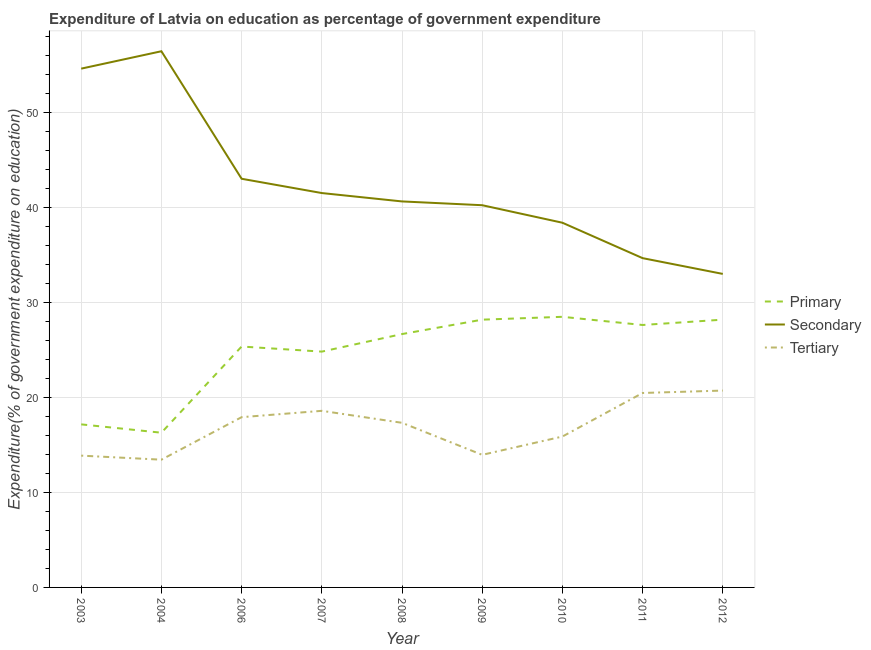How many different coloured lines are there?
Ensure brevity in your answer.  3. Is the number of lines equal to the number of legend labels?
Provide a succinct answer. Yes. What is the expenditure on primary education in 2007?
Offer a terse response. 24.82. Across all years, what is the maximum expenditure on tertiary education?
Make the answer very short. 20.72. Across all years, what is the minimum expenditure on primary education?
Provide a short and direct response. 16.29. In which year was the expenditure on tertiary education maximum?
Your answer should be compact. 2012. In which year was the expenditure on tertiary education minimum?
Offer a very short reply. 2004. What is the total expenditure on primary education in the graph?
Offer a very short reply. 222.81. What is the difference between the expenditure on primary education in 2003 and that in 2008?
Keep it short and to the point. -9.51. What is the difference between the expenditure on secondary education in 2004 and the expenditure on tertiary education in 2009?
Your answer should be very brief. 42.49. What is the average expenditure on secondary education per year?
Give a very brief answer. 42.5. In the year 2007, what is the difference between the expenditure on primary education and expenditure on secondary education?
Provide a short and direct response. -16.69. In how many years, is the expenditure on tertiary education greater than 4 %?
Your answer should be compact. 9. What is the ratio of the expenditure on secondary education in 2006 to that in 2010?
Your answer should be very brief. 1.12. What is the difference between the highest and the second highest expenditure on tertiary education?
Provide a succinct answer. 0.25. What is the difference between the highest and the lowest expenditure on primary education?
Your answer should be very brief. 12.2. In how many years, is the expenditure on secondary education greater than the average expenditure on secondary education taken over all years?
Your answer should be compact. 3. Is the sum of the expenditure on secondary education in 2004 and 2011 greater than the maximum expenditure on primary education across all years?
Make the answer very short. Yes. Is it the case that in every year, the sum of the expenditure on primary education and expenditure on secondary education is greater than the expenditure on tertiary education?
Your response must be concise. Yes. Does the expenditure on secondary education monotonically increase over the years?
Your response must be concise. No. Is the expenditure on tertiary education strictly greater than the expenditure on primary education over the years?
Provide a succinct answer. No. Is the expenditure on tertiary education strictly less than the expenditure on primary education over the years?
Keep it short and to the point. Yes. How many years are there in the graph?
Offer a very short reply. 9. What is the difference between two consecutive major ticks on the Y-axis?
Make the answer very short. 10. Where does the legend appear in the graph?
Your answer should be compact. Center right. How many legend labels are there?
Your response must be concise. 3. What is the title of the graph?
Your response must be concise. Expenditure of Latvia on education as percentage of government expenditure. What is the label or title of the X-axis?
Keep it short and to the point. Year. What is the label or title of the Y-axis?
Your response must be concise. Expenditure(% of government expenditure on education). What is the Expenditure(% of government expenditure on education) of Primary in 2003?
Your answer should be compact. 17.17. What is the Expenditure(% of government expenditure on education) in Secondary in 2003?
Provide a short and direct response. 54.61. What is the Expenditure(% of government expenditure on education) in Tertiary in 2003?
Provide a succinct answer. 13.87. What is the Expenditure(% of government expenditure on education) of Primary in 2004?
Keep it short and to the point. 16.29. What is the Expenditure(% of government expenditure on education) of Secondary in 2004?
Give a very brief answer. 56.45. What is the Expenditure(% of government expenditure on education) in Tertiary in 2004?
Your response must be concise. 13.45. What is the Expenditure(% of government expenditure on education) in Primary in 2006?
Your answer should be very brief. 25.36. What is the Expenditure(% of government expenditure on education) in Secondary in 2006?
Make the answer very short. 43.02. What is the Expenditure(% of government expenditure on education) in Tertiary in 2006?
Your response must be concise. 17.92. What is the Expenditure(% of government expenditure on education) of Primary in 2007?
Provide a short and direct response. 24.82. What is the Expenditure(% of government expenditure on education) of Secondary in 2007?
Provide a short and direct response. 41.52. What is the Expenditure(% of government expenditure on education) in Tertiary in 2007?
Offer a terse response. 18.59. What is the Expenditure(% of government expenditure on education) in Primary in 2008?
Keep it short and to the point. 26.67. What is the Expenditure(% of government expenditure on education) of Secondary in 2008?
Provide a succinct answer. 40.64. What is the Expenditure(% of government expenditure on education) in Tertiary in 2008?
Ensure brevity in your answer.  17.33. What is the Expenditure(% of government expenditure on education) in Primary in 2009?
Ensure brevity in your answer.  28.19. What is the Expenditure(% of government expenditure on education) of Secondary in 2009?
Offer a terse response. 40.24. What is the Expenditure(% of government expenditure on education) of Tertiary in 2009?
Provide a short and direct response. 13.96. What is the Expenditure(% of government expenditure on education) in Primary in 2010?
Your response must be concise. 28.49. What is the Expenditure(% of government expenditure on education) in Secondary in 2010?
Provide a succinct answer. 38.39. What is the Expenditure(% of government expenditure on education) in Tertiary in 2010?
Provide a short and direct response. 15.88. What is the Expenditure(% of government expenditure on education) of Primary in 2011?
Provide a short and direct response. 27.63. What is the Expenditure(% of government expenditure on education) of Secondary in 2011?
Make the answer very short. 34.67. What is the Expenditure(% of government expenditure on education) of Tertiary in 2011?
Provide a succinct answer. 20.47. What is the Expenditure(% of government expenditure on education) in Primary in 2012?
Make the answer very short. 28.19. What is the Expenditure(% of government expenditure on education) of Secondary in 2012?
Your answer should be very brief. 33. What is the Expenditure(% of government expenditure on education) of Tertiary in 2012?
Offer a terse response. 20.72. Across all years, what is the maximum Expenditure(% of government expenditure on education) of Primary?
Give a very brief answer. 28.49. Across all years, what is the maximum Expenditure(% of government expenditure on education) of Secondary?
Ensure brevity in your answer.  56.45. Across all years, what is the maximum Expenditure(% of government expenditure on education) in Tertiary?
Provide a succinct answer. 20.72. Across all years, what is the minimum Expenditure(% of government expenditure on education) of Primary?
Ensure brevity in your answer.  16.29. Across all years, what is the minimum Expenditure(% of government expenditure on education) of Secondary?
Offer a very short reply. 33. Across all years, what is the minimum Expenditure(% of government expenditure on education) in Tertiary?
Offer a very short reply. 13.45. What is the total Expenditure(% of government expenditure on education) of Primary in the graph?
Give a very brief answer. 222.81. What is the total Expenditure(% of government expenditure on education) in Secondary in the graph?
Offer a very short reply. 382.54. What is the total Expenditure(% of government expenditure on education) in Tertiary in the graph?
Make the answer very short. 152.2. What is the difference between the Expenditure(% of government expenditure on education) in Primary in 2003 and that in 2004?
Provide a short and direct response. 0.88. What is the difference between the Expenditure(% of government expenditure on education) in Secondary in 2003 and that in 2004?
Provide a succinct answer. -1.83. What is the difference between the Expenditure(% of government expenditure on education) in Tertiary in 2003 and that in 2004?
Give a very brief answer. 0.43. What is the difference between the Expenditure(% of government expenditure on education) in Primary in 2003 and that in 2006?
Your answer should be very brief. -8.19. What is the difference between the Expenditure(% of government expenditure on education) in Secondary in 2003 and that in 2006?
Keep it short and to the point. 11.59. What is the difference between the Expenditure(% of government expenditure on education) in Tertiary in 2003 and that in 2006?
Your answer should be compact. -4.05. What is the difference between the Expenditure(% of government expenditure on education) in Primary in 2003 and that in 2007?
Ensure brevity in your answer.  -7.66. What is the difference between the Expenditure(% of government expenditure on education) of Secondary in 2003 and that in 2007?
Provide a short and direct response. 13.1. What is the difference between the Expenditure(% of government expenditure on education) of Tertiary in 2003 and that in 2007?
Give a very brief answer. -4.72. What is the difference between the Expenditure(% of government expenditure on education) of Primary in 2003 and that in 2008?
Ensure brevity in your answer.  -9.51. What is the difference between the Expenditure(% of government expenditure on education) of Secondary in 2003 and that in 2008?
Ensure brevity in your answer.  13.98. What is the difference between the Expenditure(% of government expenditure on education) in Tertiary in 2003 and that in 2008?
Offer a terse response. -3.46. What is the difference between the Expenditure(% of government expenditure on education) in Primary in 2003 and that in 2009?
Your response must be concise. -11.02. What is the difference between the Expenditure(% of government expenditure on education) in Secondary in 2003 and that in 2009?
Offer a very short reply. 14.38. What is the difference between the Expenditure(% of government expenditure on education) in Tertiary in 2003 and that in 2009?
Provide a succinct answer. -0.08. What is the difference between the Expenditure(% of government expenditure on education) in Primary in 2003 and that in 2010?
Make the answer very short. -11.32. What is the difference between the Expenditure(% of government expenditure on education) in Secondary in 2003 and that in 2010?
Make the answer very short. 16.22. What is the difference between the Expenditure(% of government expenditure on education) in Tertiary in 2003 and that in 2010?
Make the answer very short. -2.01. What is the difference between the Expenditure(% of government expenditure on education) in Primary in 2003 and that in 2011?
Your response must be concise. -10.46. What is the difference between the Expenditure(% of government expenditure on education) of Secondary in 2003 and that in 2011?
Provide a succinct answer. 19.95. What is the difference between the Expenditure(% of government expenditure on education) of Tertiary in 2003 and that in 2011?
Make the answer very short. -6.6. What is the difference between the Expenditure(% of government expenditure on education) in Primary in 2003 and that in 2012?
Your answer should be very brief. -11.02. What is the difference between the Expenditure(% of government expenditure on education) in Secondary in 2003 and that in 2012?
Keep it short and to the point. 21.61. What is the difference between the Expenditure(% of government expenditure on education) in Tertiary in 2003 and that in 2012?
Provide a short and direct response. -6.85. What is the difference between the Expenditure(% of government expenditure on education) in Primary in 2004 and that in 2006?
Your response must be concise. -9.07. What is the difference between the Expenditure(% of government expenditure on education) in Secondary in 2004 and that in 2006?
Your answer should be compact. 13.42. What is the difference between the Expenditure(% of government expenditure on education) of Tertiary in 2004 and that in 2006?
Your answer should be compact. -4.47. What is the difference between the Expenditure(% of government expenditure on education) of Primary in 2004 and that in 2007?
Your answer should be very brief. -8.54. What is the difference between the Expenditure(% of government expenditure on education) in Secondary in 2004 and that in 2007?
Provide a short and direct response. 14.93. What is the difference between the Expenditure(% of government expenditure on education) in Tertiary in 2004 and that in 2007?
Give a very brief answer. -5.14. What is the difference between the Expenditure(% of government expenditure on education) of Primary in 2004 and that in 2008?
Your answer should be very brief. -10.39. What is the difference between the Expenditure(% of government expenditure on education) of Secondary in 2004 and that in 2008?
Make the answer very short. 15.81. What is the difference between the Expenditure(% of government expenditure on education) in Tertiary in 2004 and that in 2008?
Keep it short and to the point. -3.88. What is the difference between the Expenditure(% of government expenditure on education) of Primary in 2004 and that in 2009?
Ensure brevity in your answer.  -11.9. What is the difference between the Expenditure(% of government expenditure on education) in Secondary in 2004 and that in 2009?
Give a very brief answer. 16.21. What is the difference between the Expenditure(% of government expenditure on education) of Tertiary in 2004 and that in 2009?
Your response must be concise. -0.51. What is the difference between the Expenditure(% of government expenditure on education) of Primary in 2004 and that in 2010?
Provide a short and direct response. -12.2. What is the difference between the Expenditure(% of government expenditure on education) in Secondary in 2004 and that in 2010?
Provide a succinct answer. 18.05. What is the difference between the Expenditure(% of government expenditure on education) of Tertiary in 2004 and that in 2010?
Your response must be concise. -2.44. What is the difference between the Expenditure(% of government expenditure on education) of Primary in 2004 and that in 2011?
Give a very brief answer. -11.34. What is the difference between the Expenditure(% of government expenditure on education) of Secondary in 2004 and that in 2011?
Offer a terse response. 21.78. What is the difference between the Expenditure(% of government expenditure on education) of Tertiary in 2004 and that in 2011?
Ensure brevity in your answer.  -7.02. What is the difference between the Expenditure(% of government expenditure on education) in Primary in 2004 and that in 2012?
Offer a terse response. -11.9. What is the difference between the Expenditure(% of government expenditure on education) in Secondary in 2004 and that in 2012?
Your answer should be compact. 23.44. What is the difference between the Expenditure(% of government expenditure on education) in Tertiary in 2004 and that in 2012?
Offer a terse response. -7.28. What is the difference between the Expenditure(% of government expenditure on education) of Primary in 2006 and that in 2007?
Offer a very short reply. 0.54. What is the difference between the Expenditure(% of government expenditure on education) of Secondary in 2006 and that in 2007?
Offer a terse response. 1.5. What is the difference between the Expenditure(% of government expenditure on education) of Tertiary in 2006 and that in 2007?
Offer a terse response. -0.67. What is the difference between the Expenditure(% of government expenditure on education) of Primary in 2006 and that in 2008?
Offer a very short reply. -1.31. What is the difference between the Expenditure(% of government expenditure on education) in Secondary in 2006 and that in 2008?
Your response must be concise. 2.39. What is the difference between the Expenditure(% of government expenditure on education) in Tertiary in 2006 and that in 2008?
Your answer should be compact. 0.59. What is the difference between the Expenditure(% of government expenditure on education) of Primary in 2006 and that in 2009?
Provide a succinct answer. -2.83. What is the difference between the Expenditure(% of government expenditure on education) in Secondary in 2006 and that in 2009?
Give a very brief answer. 2.78. What is the difference between the Expenditure(% of government expenditure on education) of Tertiary in 2006 and that in 2009?
Provide a succinct answer. 3.97. What is the difference between the Expenditure(% of government expenditure on education) of Primary in 2006 and that in 2010?
Your answer should be compact. -3.13. What is the difference between the Expenditure(% of government expenditure on education) in Secondary in 2006 and that in 2010?
Offer a terse response. 4.63. What is the difference between the Expenditure(% of government expenditure on education) in Tertiary in 2006 and that in 2010?
Provide a succinct answer. 2.04. What is the difference between the Expenditure(% of government expenditure on education) in Primary in 2006 and that in 2011?
Your answer should be compact. -2.27. What is the difference between the Expenditure(% of government expenditure on education) in Secondary in 2006 and that in 2011?
Ensure brevity in your answer.  8.36. What is the difference between the Expenditure(% of government expenditure on education) in Tertiary in 2006 and that in 2011?
Ensure brevity in your answer.  -2.55. What is the difference between the Expenditure(% of government expenditure on education) in Primary in 2006 and that in 2012?
Offer a terse response. -2.83. What is the difference between the Expenditure(% of government expenditure on education) of Secondary in 2006 and that in 2012?
Your answer should be compact. 10.02. What is the difference between the Expenditure(% of government expenditure on education) in Tertiary in 2006 and that in 2012?
Offer a terse response. -2.8. What is the difference between the Expenditure(% of government expenditure on education) of Primary in 2007 and that in 2008?
Provide a short and direct response. -1.85. What is the difference between the Expenditure(% of government expenditure on education) of Secondary in 2007 and that in 2008?
Make the answer very short. 0.88. What is the difference between the Expenditure(% of government expenditure on education) in Tertiary in 2007 and that in 2008?
Provide a succinct answer. 1.26. What is the difference between the Expenditure(% of government expenditure on education) of Primary in 2007 and that in 2009?
Your answer should be very brief. -3.36. What is the difference between the Expenditure(% of government expenditure on education) of Secondary in 2007 and that in 2009?
Your answer should be compact. 1.28. What is the difference between the Expenditure(% of government expenditure on education) in Tertiary in 2007 and that in 2009?
Your response must be concise. 4.63. What is the difference between the Expenditure(% of government expenditure on education) of Primary in 2007 and that in 2010?
Offer a very short reply. -3.66. What is the difference between the Expenditure(% of government expenditure on education) in Secondary in 2007 and that in 2010?
Offer a terse response. 3.12. What is the difference between the Expenditure(% of government expenditure on education) of Tertiary in 2007 and that in 2010?
Give a very brief answer. 2.71. What is the difference between the Expenditure(% of government expenditure on education) of Primary in 2007 and that in 2011?
Offer a terse response. -2.8. What is the difference between the Expenditure(% of government expenditure on education) of Secondary in 2007 and that in 2011?
Give a very brief answer. 6.85. What is the difference between the Expenditure(% of government expenditure on education) of Tertiary in 2007 and that in 2011?
Provide a short and direct response. -1.88. What is the difference between the Expenditure(% of government expenditure on education) of Primary in 2007 and that in 2012?
Offer a terse response. -3.37. What is the difference between the Expenditure(% of government expenditure on education) of Secondary in 2007 and that in 2012?
Your answer should be very brief. 8.51. What is the difference between the Expenditure(% of government expenditure on education) of Tertiary in 2007 and that in 2012?
Your response must be concise. -2.13. What is the difference between the Expenditure(% of government expenditure on education) in Primary in 2008 and that in 2009?
Your answer should be compact. -1.52. What is the difference between the Expenditure(% of government expenditure on education) in Secondary in 2008 and that in 2009?
Offer a terse response. 0.4. What is the difference between the Expenditure(% of government expenditure on education) in Tertiary in 2008 and that in 2009?
Your response must be concise. 3.37. What is the difference between the Expenditure(% of government expenditure on education) of Primary in 2008 and that in 2010?
Your response must be concise. -1.82. What is the difference between the Expenditure(% of government expenditure on education) in Secondary in 2008 and that in 2010?
Offer a terse response. 2.24. What is the difference between the Expenditure(% of government expenditure on education) in Tertiary in 2008 and that in 2010?
Provide a succinct answer. 1.45. What is the difference between the Expenditure(% of government expenditure on education) of Primary in 2008 and that in 2011?
Offer a very short reply. -0.96. What is the difference between the Expenditure(% of government expenditure on education) in Secondary in 2008 and that in 2011?
Make the answer very short. 5.97. What is the difference between the Expenditure(% of government expenditure on education) of Tertiary in 2008 and that in 2011?
Ensure brevity in your answer.  -3.14. What is the difference between the Expenditure(% of government expenditure on education) of Primary in 2008 and that in 2012?
Keep it short and to the point. -1.52. What is the difference between the Expenditure(% of government expenditure on education) of Secondary in 2008 and that in 2012?
Your response must be concise. 7.63. What is the difference between the Expenditure(% of government expenditure on education) in Tertiary in 2008 and that in 2012?
Keep it short and to the point. -3.39. What is the difference between the Expenditure(% of government expenditure on education) of Secondary in 2009 and that in 2010?
Keep it short and to the point. 1.84. What is the difference between the Expenditure(% of government expenditure on education) of Tertiary in 2009 and that in 2010?
Offer a very short reply. -1.93. What is the difference between the Expenditure(% of government expenditure on education) of Primary in 2009 and that in 2011?
Your response must be concise. 0.56. What is the difference between the Expenditure(% of government expenditure on education) of Secondary in 2009 and that in 2011?
Provide a succinct answer. 5.57. What is the difference between the Expenditure(% of government expenditure on education) of Tertiary in 2009 and that in 2011?
Provide a succinct answer. -6.51. What is the difference between the Expenditure(% of government expenditure on education) in Primary in 2009 and that in 2012?
Give a very brief answer. -0. What is the difference between the Expenditure(% of government expenditure on education) of Secondary in 2009 and that in 2012?
Your response must be concise. 7.23. What is the difference between the Expenditure(% of government expenditure on education) of Tertiary in 2009 and that in 2012?
Your response must be concise. -6.77. What is the difference between the Expenditure(% of government expenditure on education) in Primary in 2010 and that in 2011?
Your response must be concise. 0.86. What is the difference between the Expenditure(% of government expenditure on education) in Secondary in 2010 and that in 2011?
Make the answer very short. 3.73. What is the difference between the Expenditure(% of government expenditure on education) of Tertiary in 2010 and that in 2011?
Your answer should be very brief. -4.59. What is the difference between the Expenditure(% of government expenditure on education) of Primary in 2010 and that in 2012?
Make the answer very short. 0.3. What is the difference between the Expenditure(% of government expenditure on education) in Secondary in 2010 and that in 2012?
Provide a short and direct response. 5.39. What is the difference between the Expenditure(% of government expenditure on education) in Tertiary in 2010 and that in 2012?
Your answer should be compact. -4.84. What is the difference between the Expenditure(% of government expenditure on education) of Primary in 2011 and that in 2012?
Give a very brief answer. -0.56. What is the difference between the Expenditure(% of government expenditure on education) in Secondary in 2011 and that in 2012?
Keep it short and to the point. 1.66. What is the difference between the Expenditure(% of government expenditure on education) in Tertiary in 2011 and that in 2012?
Your response must be concise. -0.25. What is the difference between the Expenditure(% of government expenditure on education) of Primary in 2003 and the Expenditure(% of government expenditure on education) of Secondary in 2004?
Your answer should be compact. -39.28. What is the difference between the Expenditure(% of government expenditure on education) in Primary in 2003 and the Expenditure(% of government expenditure on education) in Tertiary in 2004?
Your answer should be very brief. 3.72. What is the difference between the Expenditure(% of government expenditure on education) of Secondary in 2003 and the Expenditure(% of government expenditure on education) of Tertiary in 2004?
Provide a short and direct response. 41.17. What is the difference between the Expenditure(% of government expenditure on education) in Primary in 2003 and the Expenditure(% of government expenditure on education) in Secondary in 2006?
Ensure brevity in your answer.  -25.86. What is the difference between the Expenditure(% of government expenditure on education) in Primary in 2003 and the Expenditure(% of government expenditure on education) in Tertiary in 2006?
Provide a short and direct response. -0.76. What is the difference between the Expenditure(% of government expenditure on education) of Secondary in 2003 and the Expenditure(% of government expenditure on education) of Tertiary in 2006?
Keep it short and to the point. 36.69. What is the difference between the Expenditure(% of government expenditure on education) of Primary in 2003 and the Expenditure(% of government expenditure on education) of Secondary in 2007?
Make the answer very short. -24.35. What is the difference between the Expenditure(% of government expenditure on education) of Primary in 2003 and the Expenditure(% of government expenditure on education) of Tertiary in 2007?
Make the answer very short. -1.42. What is the difference between the Expenditure(% of government expenditure on education) in Secondary in 2003 and the Expenditure(% of government expenditure on education) in Tertiary in 2007?
Your response must be concise. 36.02. What is the difference between the Expenditure(% of government expenditure on education) of Primary in 2003 and the Expenditure(% of government expenditure on education) of Secondary in 2008?
Offer a very short reply. -23.47. What is the difference between the Expenditure(% of government expenditure on education) of Primary in 2003 and the Expenditure(% of government expenditure on education) of Tertiary in 2008?
Offer a terse response. -0.16. What is the difference between the Expenditure(% of government expenditure on education) of Secondary in 2003 and the Expenditure(% of government expenditure on education) of Tertiary in 2008?
Your answer should be compact. 37.28. What is the difference between the Expenditure(% of government expenditure on education) of Primary in 2003 and the Expenditure(% of government expenditure on education) of Secondary in 2009?
Ensure brevity in your answer.  -23.07. What is the difference between the Expenditure(% of government expenditure on education) of Primary in 2003 and the Expenditure(% of government expenditure on education) of Tertiary in 2009?
Offer a terse response. 3.21. What is the difference between the Expenditure(% of government expenditure on education) in Secondary in 2003 and the Expenditure(% of government expenditure on education) in Tertiary in 2009?
Your response must be concise. 40.66. What is the difference between the Expenditure(% of government expenditure on education) of Primary in 2003 and the Expenditure(% of government expenditure on education) of Secondary in 2010?
Offer a terse response. -21.23. What is the difference between the Expenditure(% of government expenditure on education) in Primary in 2003 and the Expenditure(% of government expenditure on education) in Tertiary in 2010?
Ensure brevity in your answer.  1.28. What is the difference between the Expenditure(% of government expenditure on education) in Secondary in 2003 and the Expenditure(% of government expenditure on education) in Tertiary in 2010?
Offer a terse response. 38.73. What is the difference between the Expenditure(% of government expenditure on education) in Primary in 2003 and the Expenditure(% of government expenditure on education) in Secondary in 2011?
Make the answer very short. -17.5. What is the difference between the Expenditure(% of government expenditure on education) in Primary in 2003 and the Expenditure(% of government expenditure on education) in Tertiary in 2011?
Your response must be concise. -3.3. What is the difference between the Expenditure(% of government expenditure on education) in Secondary in 2003 and the Expenditure(% of government expenditure on education) in Tertiary in 2011?
Ensure brevity in your answer.  34.14. What is the difference between the Expenditure(% of government expenditure on education) in Primary in 2003 and the Expenditure(% of government expenditure on education) in Secondary in 2012?
Your response must be concise. -15.84. What is the difference between the Expenditure(% of government expenditure on education) in Primary in 2003 and the Expenditure(% of government expenditure on education) in Tertiary in 2012?
Keep it short and to the point. -3.56. What is the difference between the Expenditure(% of government expenditure on education) of Secondary in 2003 and the Expenditure(% of government expenditure on education) of Tertiary in 2012?
Your answer should be compact. 33.89. What is the difference between the Expenditure(% of government expenditure on education) of Primary in 2004 and the Expenditure(% of government expenditure on education) of Secondary in 2006?
Offer a terse response. -26.74. What is the difference between the Expenditure(% of government expenditure on education) of Primary in 2004 and the Expenditure(% of government expenditure on education) of Tertiary in 2006?
Provide a short and direct response. -1.64. What is the difference between the Expenditure(% of government expenditure on education) of Secondary in 2004 and the Expenditure(% of government expenditure on education) of Tertiary in 2006?
Offer a terse response. 38.52. What is the difference between the Expenditure(% of government expenditure on education) in Primary in 2004 and the Expenditure(% of government expenditure on education) in Secondary in 2007?
Ensure brevity in your answer.  -25.23. What is the difference between the Expenditure(% of government expenditure on education) of Primary in 2004 and the Expenditure(% of government expenditure on education) of Tertiary in 2007?
Offer a very short reply. -2.3. What is the difference between the Expenditure(% of government expenditure on education) of Secondary in 2004 and the Expenditure(% of government expenditure on education) of Tertiary in 2007?
Your answer should be very brief. 37.85. What is the difference between the Expenditure(% of government expenditure on education) of Primary in 2004 and the Expenditure(% of government expenditure on education) of Secondary in 2008?
Your answer should be compact. -24.35. What is the difference between the Expenditure(% of government expenditure on education) of Primary in 2004 and the Expenditure(% of government expenditure on education) of Tertiary in 2008?
Keep it short and to the point. -1.04. What is the difference between the Expenditure(% of government expenditure on education) of Secondary in 2004 and the Expenditure(% of government expenditure on education) of Tertiary in 2008?
Ensure brevity in your answer.  39.11. What is the difference between the Expenditure(% of government expenditure on education) of Primary in 2004 and the Expenditure(% of government expenditure on education) of Secondary in 2009?
Make the answer very short. -23.95. What is the difference between the Expenditure(% of government expenditure on education) in Primary in 2004 and the Expenditure(% of government expenditure on education) in Tertiary in 2009?
Provide a succinct answer. 2.33. What is the difference between the Expenditure(% of government expenditure on education) of Secondary in 2004 and the Expenditure(% of government expenditure on education) of Tertiary in 2009?
Provide a succinct answer. 42.49. What is the difference between the Expenditure(% of government expenditure on education) of Primary in 2004 and the Expenditure(% of government expenditure on education) of Secondary in 2010?
Make the answer very short. -22.11. What is the difference between the Expenditure(% of government expenditure on education) of Primary in 2004 and the Expenditure(% of government expenditure on education) of Tertiary in 2010?
Offer a very short reply. 0.4. What is the difference between the Expenditure(% of government expenditure on education) of Secondary in 2004 and the Expenditure(% of government expenditure on education) of Tertiary in 2010?
Your answer should be compact. 40.56. What is the difference between the Expenditure(% of government expenditure on education) of Primary in 2004 and the Expenditure(% of government expenditure on education) of Secondary in 2011?
Your answer should be compact. -18.38. What is the difference between the Expenditure(% of government expenditure on education) of Primary in 2004 and the Expenditure(% of government expenditure on education) of Tertiary in 2011?
Ensure brevity in your answer.  -4.18. What is the difference between the Expenditure(% of government expenditure on education) of Secondary in 2004 and the Expenditure(% of government expenditure on education) of Tertiary in 2011?
Provide a short and direct response. 35.98. What is the difference between the Expenditure(% of government expenditure on education) in Primary in 2004 and the Expenditure(% of government expenditure on education) in Secondary in 2012?
Keep it short and to the point. -16.72. What is the difference between the Expenditure(% of government expenditure on education) of Primary in 2004 and the Expenditure(% of government expenditure on education) of Tertiary in 2012?
Your answer should be compact. -4.44. What is the difference between the Expenditure(% of government expenditure on education) in Secondary in 2004 and the Expenditure(% of government expenditure on education) in Tertiary in 2012?
Your answer should be very brief. 35.72. What is the difference between the Expenditure(% of government expenditure on education) of Primary in 2006 and the Expenditure(% of government expenditure on education) of Secondary in 2007?
Make the answer very short. -16.16. What is the difference between the Expenditure(% of government expenditure on education) in Primary in 2006 and the Expenditure(% of government expenditure on education) in Tertiary in 2007?
Offer a very short reply. 6.77. What is the difference between the Expenditure(% of government expenditure on education) in Secondary in 2006 and the Expenditure(% of government expenditure on education) in Tertiary in 2007?
Provide a short and direct response. 24.43. What is the difference between the Expenditure(% of government expenditure on education) of Primary in 2006 and the Expenditure(% of government expenditure on education) of Secondary in 2008?
Offer a terse response. -15.28. What is the difference between the Expenditure(% of government expenditure on education) of Primary in 2006 and the Expenditure(% of government expenditure on education) of Tertiary in 2008?
Make the answer very short. 8.03. What is the difference between the Expenditure(% of government expenditure on education) in Secondary in 2006 and the Expenditure(% of government expenditure on education) in Tertiary in 2008?
Provide a short and direct response. 25.69. What is the difference between the Expenditure(% of government expenditure on education) in Primary in 2006 and the Expenditure(% of government expenditure on education) in Secondary in 2009?
Keep it short and to the point. -14.88. What is the difference between the Expenditure(% of government expenditure on education) of Primary in 2006 and the Expenditure(% of government expenditure on education) of Tertiary in 2009?
Keep it short and to the point. 11.4. What is the difference between the Expenditure(% of government expenditure on education) in Secondary in 2006 and the Expenditure(% of government expenditure on education) in Tertiary in 2009?
Your answer should be very brief. 29.06. What is the difference between the Expenditure(% of government expenditure on education) of Primary in 2006 and the Expenditure(% of government expenditure on education) of Secondary in 2010?
Your response must be concise. -13.03. What is the difference between the Expenditure(% of government expenditure on education) in Primary in 2006 and the Expenditure(% of government expenditure on education) in Tertiary in 2010?
Offer a very short reply. 9.48. What is the difference between the Expenditure(% of government expenditure on education) of Secondary in 2006 and the Expenditure(% of government expenditure on education) of Tertiary in 2010?
Keep it short and to the point. 27.14. What is the difference between the Expenditure(% of government expenditure on education) of Primary in 2006 and the Expenditure(% of government expenditure on education) of Secondary in 2011?
Your response must be concise. -9.31. What is the difference between the Expenditure(% of government expenditure on education) of Primary in 2006 and the Expenditure(% of government expenditure on education) of Tertiary in 2011?
Keep it short and to the point. 4.89. What is the difference between the Expenditure(% of government expenditure on education) in Secondary in 2006 and the Expenditure(% of government expenditure on education) in Tertiary in 2011?
Your response must be concise. 22.55. What is the difference between the Expenditure(% of government expenditure on education) in Primary in 2006 and the Expenditure(% of government expenditure on education) in Secondary in 2012?
Provide a succinct answer. -7.64. What is the difference between the Expenditure(% of government expenditure on education) in Primary in 2006 and the Expenditure(% of government expenditure on education) in Tertiary in 2012?
Your answer should be very brief. 4.64. What is the difference between the Expenditure(% of government expenditure on education) in Secondary in 2006 and the Expenditure(% of government expenditure on education) in Tertiary in 2012?
Offer a terse response. 22.3. What is the difference between the Expenditure(% of government expenditure on education) in Primary in 2007 and the Expenditure(% of government expenditure on education) in Secondary in 2008?
Offer a terse response. -15.81. What is the difference between the Expenditure(% of government expenditure on education) in Primary in 2007 and the Expenditure(% of government expenditure on education) in Tertiary in 2008?
Give a very brief answer. 7.49. What is the difference between the Expenditure(% of government expenditure on education) in Secondary in 2007 and the Expenditure(% of government expenditure on education) in Tertiary in 2008?
Give a very brief answer. 24.19. What is the difference between the Expenditure(% of government expenditure on education) of Primary in 2007 and the Expenditure(% of government expenditure on education) of Secondary in 2009?
Provide a succinct answer. -15.41. What is the difference between the Expenditure(% of government expenditure on education) in Primary in 2007 and the Expenditure(% of government expenditure on education) in Tertiary in 2009?
Offer a terse response. 10.87. What is the difference between the Expenditure(% of government expenditure on education) of Secondary in 2007 and the Expenditure(% of government expenditure on education) of Tertiary in 2009?
Provide a short and direct response. 27.56. What is the difference between the Expenditure(% of government expenditure on education) in Primary in 2007 and the Expenditure(% of government expenditure on education) in Secondary in 2010?
Give a very brief answer. -13.57. What is the difference between the Expenditure(% of government expenditure on education) in Primary in 2007 and the Expenditure(% of government expenditure on education) in Tertiary in 2010?
Your answer should be very brief. 8.94. What is the difference between the Expenditure(% of government expenditure on education) of Secondary in 2007 and the Expenditure(% of government expenditure on education) of Tertiary in 2010?
Provide a short and direct response. 25.63. What is the difference between the Expenditure(% of government expenditure on education) in Primary in 2007 and the Expenditure(% of government expenditure on education) in Secondary in 2011?
Offer a very short reply. -9.84. What is the difference between the Expenditure(% of government expenditure on education) of Primary in 2007 and the Expenditure(% of government expenditure on education) of Tertiary in 2011?
Your response must be concise. 4.35. What is the difference between the Expenditure(% of government expenditure on education) in Secondary in 2007 and the Expenditure(% of government expenditure on education) in Tertiary in 2011?
Ensure brevity in your answer.  21.05. What is the difference between the Expenditure(% of government expenditure on education) of Primary in 2007 and the Expenditure(% of government expenditure on education) of Secondary in 2012?
Ensure brevity in your answer.  -8.18. What is the difference between the Expenditure(% of government expenditure on education) in Primary in 2007 and the Expenditure(% of government expenditure on education) in Tertiary in 2012?
Your answer should be compact. 4.1. What is the difference between the Expenditure(% of government expenditure on education) of Secondary in 2007 and the Expenditure(% of government expenditure on education) of Tertiary in 2012?
Provide a short and direct response. 20.79. What is the difference between the Expenditure(% of government expenditure on education) of Primary in 2008 and the Expenditure(% of government expenditure on education) of Secondary in 2009?
Provide a succinct answer. -13.56. What is the difference between the Expenditure(% of government expenditure on education) in Primary in 2008 and the Expenditure(% of government expenditure on education) in Tertiary in 2009?
Provide a succinct answer. 12.71. What is the difference between the Expenditure(% of government expenditure on education) of Secondary in 2008 and the Expenditure(% of government expenditure on education) of Tertiary in 2009?
Provide a short and direct response. 26.68. What is the difference between the Expenditure(% of government expenditure on education) of Primary in 2008 and the Expenditure(% of government expenditure on education) of Secondary in 2010?
Your response must be concise. -11.72. What is the difference between the Expenditure(% of government expenditure on education) of Primary in 2008 and the Expenditure(% of government expenditure on education) of Tertiary in 2010?
Your answer should be compact. 10.79. What is the difference between the Expenditure(% of government expenditure on education) of Secondary in 2008 and the Expenditure(% of government expenditure on education) of Tertiary in 2010?
Offer a terse response. 24.75. What is the difference between the Expenditure(% of government expenditure on education) of Primary in 2008 and the Expenditure(% of government expenditure on education) of Secondary in 2011?
Give a very brief answer. -7.99. What is the difference between the Expenditure(% of government expenditure on education) in Primary in 2008 and the Expenditure(% of government expenditure on education) in Tertiary in 2011?
Give a very brief answer. 6.2. What is the difference between the Expenditure(% of government expenditure on education) of Secondary in 2008 and the Expenditure(% of government expenditure on education) of Tertiary in 2011?
Your response must be concise. 20.17. What is the difference between the Expenditure(% of government expenditure on education) in Primary in 2008 and the Expenditure(% of government expenditure on education) in Secondary in 2012?
Ensure brevity in your answer.  -6.33. What is the difference between the Expenditure(% of government expenditure on education) in Primary in 2008 and the Expenditure(% of government expenditure on education) in Tertiary in 2012?
Make the answer very short. 5.95. What is the difference between the Expenditure(% of government expenditure on education) of Secondary in 2008 and the Expenditure(% of government expenditure on education) of Tertiary in 2012?
Keep it short and to the point. 19.91. What is the difference between the Expenditure(% of government expenditure on education) in Primary in 2009 and the Expenditure(% of government expenditure on education) in Secondary in 2010?
Give a very brief answer. -10.2. What is the difference between the Expenditure(% of government expenditure on education) of Primary in 2009 and the Expenditure(% of government expenditure on education) of Tertiary in 2010?
Provide a short and direct response. 12.31. What is the difference between the Expenditure(% of government expenditure on education) in Secondary in 2009 and the Expenditure(% of government expenditure on education) in Tertiary in 2010?
Offer a very short reply. 24.35. What is the difference between the Expenditure(% of government expenditure on education) in Primary in 2009 and the Expenditure(% of government expenditure on education) in Secondary in 2011?
Offer a very short reply. -6.48. What is the difference between the Expenditure(% of government expenditure on education) of Primary in 2009 and the Expenditure(% of government expenditure on education) of Tertiary in 2011?
Your answer should be very brief. 7.72. What is the difference between the Expenditure(% of government expenditure on education) in Secondary in 2009 and the Expenditure(% of government expenditure on education) in Tertiary in 2011?
Offer a very short reply. 19.77. What is the difference between the Expenditure(% of government expenditure on education) of Primary in 2009 and the Expenditure(% of government expenditure on education) of Secondary in 2012?
Your answer should be very brief. -4.82. What is the difference between the Expenditure(% of government expenditure on education) of Primary in 2009 and the Expenditure(% of government expenditure on education) of Tertiary in 2012?
Give a very brief answer. 7.47. What is the difference between the Expenditure(% of government expenditure on education) in Secondary in 2009 and the Expenditure(% of government expenditure on education) in Tertiary in 2012?
Provide a short and direct response. 19.51. What is the difference between the Expenditure(% of government expenditure on education) in Primary in 2010 and the Expenditure(% of government expenditure on education) in Secondary in 2011?
Make the answer very short. -6.18. What is the difference between the Expenditure(% of government expenditure on education) in Primary in 2010 and the Expenditure(% of government expenditure on education) in Tertiary in 2011?
Ensure brevity in your answer.  8.02. What is the difference between the Expenditure(% of government expenditure on education) of Secondary in 2010 and the Expenditure(% of government expenditure on education) of Tertiary in 2011?
Provide a short and direct response. 17.92. What is the difference between the Expenditure(% of government expenditure on education) in Primary in 2010 and the Expenditure(% of government expenditure on education) in Secondary in 2012?
Provide a short and direct response. -4.52. What is the difference between the Expenditure(% of government expenditure on education) of Primary in 2010 and the Expenditure(% of government expenditure on education) of Tertiary in 2012?
Your answer should be compact. 7.77. What is the difference between the Expenditure(% of government expenditure on education) in Secondary in 2010 and the Expenditure(% of government expenditure on education) in Tertiary in 2012?
Your answer should be very brief. 17.67. What is the difference between the Expenditure(% of government expenditure on education) in Primary in 2011 and the Expenditure(% of government expenditure on education) in Secondary in 2012?
Your response must be concise. -5.38. What is the difference between the Expenditure(% of government expenditure on education) in Primary in 2011 and the Expenditure(% of government expenditure on education) in Tertiary in 2012?
Keep it short and to the point. 6.9. What is the difference between the Expenditure(% of government expenditure on education) of Secondary in 2011 and the Expenditure(% of government expenditure on education) of Tertiary in 2012?
Keep it short and to the point. 13.94. What is the average Expenditure(% of government expenditure on education) in Primary per year?
Keep it short and to the point. 24.76. What is the average Expenditure(% of government expenditure on education) of Secondary per year?
Provide a short and direct response. 42.5. What is the average Expenditure(% of government expenditure on education) in Tertiary per year?
Your response must be concise. 16.91. In the year 2003, what is the difference between the Expenditure(% of government expenditure on education) in Primary and Expenditure(% of government expenditure on education) in Secondary?
Give a very brief answer. -37.45. In the year 2003, what is the difference between the Expenditure(% of government expenditure on education) of Primary and Expenditure(% of government expenditure on education) of Tertiary?
Your answer should be very brief. 3.29. In the year 2003, what is the difference between the Expenditure(% of government expenditure on education) of Secondary and Expenditure(% of government expenditure on education) of Tertiary?
Your response must be concise. 40.74. In the year 2004, what is the difference between the Expenditure(% of government expenditure on education) of Primary and Expenditure(% of government expenditure on education) of Secondary?
Ensure brevity in your answer.  -40.16. In the year 2004, what is the difference between the Expenditure(% of government expenditure on education) in Primary and Expenditure(% of government expenditure on education) in Tertiary?
Make the answer very short. 2.84. In the year 2004, what is the difference between the Expenditure(% of government expenditure on education) in Secondary and Expenditure(% of government expenditure on education) in Tertiary?
Offer a terse response. 43. In the year 2006, what is the difference between the Expenditure(% of government expenditure on education) of Primary and Expenditure(% of government expenditure on education) of Secondary?
Your response must be concise. -17.66. In the year 2006, what is the difference between the Expenditure(% of government expenditure on education) in Primary and Expenditure(% of government expenditure on education) in Tertiary?
Keep it short and to the point. 7.44. In the year 2006, what is the difference between the Expenditure(% of government expenditure on education) of Secondary and Expenditure(% of government expenditure on education) of Tertiary?
Give a very brief answer. 25.1. In the year 2007, what is the difference between the Expenditure(% of government expenditure on education) of Primary and Expenditure(% of government expenditure on education) of Secondary?
Your answer should be compact. -16.69. In the year 2007, what is the difference between the Expenditure(% of government expenditure on education) in Primary and Expenditure(% of government expenditure on education) in Tertiary?
Your answer should be compact. 6.23. In the year 2007, what is the difference between the Expenditure(% of government expenditure on education) in Secondary and Expenditure(% of government expenditure on education) in Tertiary?
Ensure brevity in your answer.  22.93. In the year 2008, what is the difference between the Expenditure(% of government expenditure on education) in Primary and Expenditure(% of government expenditure on education) in Secondary?
Give a very brief answer. -13.96. In the year 2008, what is the difference between the Expenditure(% of government expenditure on education) in Primary and Expenditure(% of government expenditure on education) in Tertiary?
Your answer should be very brief. 9.34. In the year 2008, what is the difference between the Expenditure(% of government expenditure on education) of Secondary and Expenditure(% of government expenditure on education) of Tertiary?
Your response must be concise. 23.3. In the year 2009, what is the difference between the Expenditure(% of government expenditure on education) of Primary and Expenditure(% of government expenditure on education) of Secondary?
Keep it short and to the point. -12.05. In the year 2009, what is the difference between the Expenditure(% of government expenditure on education) of Primary and Expenditure(% of government expenditure on education) of Tertiary?
Ensure brevity in your answer.  14.23. In the year 2009, what is the difference between the Expenditure(% of government expenditure on education) in Secondary and Expenditure(% of government expenditure on education) in Tertiary?
Provide a succinct answer. 26.28. In the year 2010, what is the difference between the Expenditure(% of government expenditure on education) in Primary and Expenditure(% of government expenditure on education) in Secondary?
Give a very brief answer. -9.9. In the year 2010, what is the difference between the Expenditure(% of government expenditure on education) of Primary and Expenditure(% of government expenditure on education) of Tertiary?
Your answer should be very brief. 12.61. In the year 2010, what is the difference between the Expenditure(% of government expenditure on education) of Secondary and Expenditure(% of government expenditure on education) of Tertiary?
Your response must be concise. 22.51. In the year 2011, what is the difference between the Expenditure(% of government expenditure on education) of Primary and Expenditure(% of government expenditure on education) of Secondary?
Offer a very short reply. -7.04. In the year 2011, what is the difference between the Expenditure(% of government expenditure on education) in Primary and Expenditure(% of government expenditure on education) in Tertiary?
Ensure brevity in your answer.  7.16. In the year 2011, what is the difference between the Expenditure(% of government expenditure on education) in Secondary and Expenditure(% of government expenditure on education) in Tertiary?
Ensure brevity in your answer.  14.19. In the year 2012, what is the difference between the Expenditure(% of government expenditure on education) of Primary and Expenditure(% of government expenditure on education) of Secondary?
Give a very brief answer. -4.81. In the year 2012, what is the difference between the Expenditure(% of government expenditure on education) in Primary and Expenditure(% of government expenditure on education) in Tertiary?
Your response must be concise. 7.47. In the year 2012, what is the difference between the Expenditure(% of government expenditure on education) of Secondary and Expenditure(% of government expenditure on education) of Tertiary?
Give a very brief answer. 12.28. What is the ratio of the Expenditure(% of government expenditure on education) of Primary in 2003 to that in 2004?
Your response must be concise. 1.05. What is the ratio of the Expenditure(% of government expenditure on education) of Secondary in 2003 to that in 2004?
Keep it short and to the point. 0.97. What is the ratio of the Expenditure(% of government expenditure on education) in Tertiary in 2003 to that in 2004?
Ensure brevity in your answer.  1.03. What is the ratio of the Expenditure(% of government expenditure on education) in Primary in 2003 to that in 2006?
Give a very brief answer. 0.68. What is the ratio of the Expenditure(% of government expenditure on education) of Secondary in 2003 to that in 2006?
Provide a succinct answer. 1.27. What is the ratio of the Expenditure(% of government expenditure on education) in Tertiary in 2003 to that in 2006?
Your answer should be compact. 0.77. What is the ratio of the Expenditure(% of government expenditure on education) of Primary in 2003 to that in 2007?
Offer a very short reply. 0.69. What is the ratio of the Expenditure(% of government expenditure on education) of Secondary in 2003 to that in 2007?
Make the answer very short. 1.32. What is the ratio of the Expenditure(% of government expenditure on education) in Tertiary in 2003 to that in 2007?
Provide a short and direct response. 0.75. What is the ratio of the Expenditure(% of government expenditure on education) in Primary in 2003 to that in 2008?
Your answer should be compact. 0.64. What is the ratio of the Expenditure(% of government expenditure on education) in Secondary in 2003 to that in 2008?
Make the answer very short. 1.34. What is the ratio of the Expenditure(% of government expenditure on education) of Tertiary in 2003 to that in 2008?
Your answer should be compact. 0.8. What is the ratio of the Expenditure(% of government expenditure on education) in Primary in 2003 to that in 2009?
Keep it short and to the point. 0.61. What is the ratio of the Expenditure(% of government expenditure on education) in Secondary in 2003 to that in 2009?
Make the answer very short. 1.36. What is the ratio of the Expenditure(% of government expenditure on education) of Primary in 2003 to that in 2010?
Ensure brevity in your answer.  0.6. What is the ratio of the Expenditure(% of government expenditure on education) in Secondary in 2003 to that in 2010?
Offer a terse response. 1.42. What is the ratio of the Expenditure(% of government expenditure on education) in Tertiary in 2003 to that in 2010?
Your answer should be compact. 0.87. What is the ratio of the Expenditure(% of government expenditure on education) in Primary in 2003 to that in 2011?
Offer a terse response. 0.62. What is the ratio of the Expenditure(% of government expenditure on education) in Secondary in 2003 to that in 2011?
Ensure brevity in your answer.  1.58. What is the ratio of the Expenditure(% of government expenditure on education) in Tertiary in 2003 to that in 2011?
Your answer should be compact. 0.68. What is the ratio of the Expenditure(% of government expenditure on education) of Primary in 2003 to that in 2012?
Your answer should be very brief. 0.61. What is the ratio of the Expenditure(% of government expenditure on education) in Secondary in 2003 to that in 2012?
Your response must be concise. 1.65. What is the ratio of the Expenditure(% of government expenditure on education) of Tertiary in 2003 to that in 2012?
Your answer should be compact. 0.67. What is the ratio of the Expenditure(% of government expenditure on education) in Primary in 2004 to that in 2006?
Keep it short and to the point. 0.64. What is the ratio of the Expenditure(% of government expenditure on education) in Secondary in 2004 to that in 2006?
Keep it short and to the point. 1.31. What is the ratio of the Expenditure(% of government expenditure on education) of Tertiary in 2004 to that in 2006?
Make the answer very short. 0.75. What is the ratio of the Expenditure(% of government expenditure on education) of Primary in 2004 to that in 2007?
Ensure brevity in your answer.  0.66. What is the ratio of the Expenditure(% of government expenditure on education) in Secondary in 2004 to that in 2007?
Provide a short and direct response. 1.36. What is the ratio of the Expenditure(% of government expenditure on education) in Tertiary in 2004 to that in 2007?
Offer a very short reply. 0.72. What is the ratio of the Expenditure(% of government expenditure on education) in Primary in 2004 to that in 2008?
Ensure brevity in your answer.  0.61. What is the ratio of the Expenditure(% of government expenditure on education) in Secondary in 2004 to that in 2008?
Make the answer very short. 1.39. What is the ratio of the Expenditure(% of government expenditure on education) of Tertiary in 2004 to that in 2008?
Your response must be concise. 0.78. What is the ratio of the Expenditure(% of government expenditure on education) in Primary in 2004 to that in 2009?
Give a very brief answer. 0.58. What is the ratio of the Expenditure(% of government expenditure on education) of Secondary in 2004 to that in 2009?
Give a very brief answer. 1.4. What is the ratio of the Expenditure(% of government expenditure on education) of Tertiary in 2004 to that in 2009?
Make the answer very short. 0.96. What is the ratio of the Expenditure(% of government expenditure on education) of Primary in 2004 to that in 2010?
Offer a terse response. 0.57. What is the ratio of the Expenditure(% of government expenditure on education) in Secondary in 2004 to that in 2010?
Make the answer very short. 1.47. What is the ratio of the Expenditure(% of government expenditure on education) in Tertiary in 2004 to that in 2010?
Ensure brevity in your answer.  0.85. What is the ratio of the Expenditure(% of government expenditure on education) of Primary in 2004 to that in 2011?
Provide a short and direct response. 0.59. What is the ratio of the Expenditure(% of government expenditure on education) in Secondary in 2004 to that in 2011?
Provide a short and direct response. 1.63. What is the ratio of the Expenditure(% of government expenditure on education) of Tertiary in 2004 to that in 2011?
Your answer should be compact. 0.66. What is the ratio of the Expenditure(% of government expenditure on education) of Primary in 2004 to that in 2012?
Ensure brevity in your answer.  0.58. What is the ratio of the Expenditure(% of government expenditure on education) in Secondary in 2004 to that in 2012?
Give a very brief answer. 1.71. What is the ratio of the Expenditure(% of government expenditure on education) in Tertiary in 2004 to that in 2012?
Provide a short and direct response. 0.65. What is the ratio of the Expenditure(% of government expenditure on education) in Primary in 2006 to that in 2007?
Your response must be concise. 1.02. What is the ratio of the Expenditure(% of government expenditure on education) of Secondary in 2006 to that in 2007?
Provide a short and direct response. 1.04. What is the ratio of the Expenditure(% of government expenditure on education) in Tertiary in 2006 to that in 2007?
Ensure brevity in your answer.  0.96. What is the ratio of the Expenditure(% of government expenditure on education) of Primary in 2006 to that in 2008?
Make the answer very short. 0.95. What is the ratio of the Expenditure(% of government expenditure on education) in Secondary in 2006 to that in 2008?
Provide a succinct answer. 1.06. What is the ratio of the Expenditure(% of government expenditure on education) of Tertiary in 2006 to that in 2008?
Provide a succinct answer. 1.03. What is the ratio of the Expenditure(% of government expenditure on education) in Primary in 2006 to that in 2009?
Your answer should be very brief. 0.9. What is the ratio of the Expenditure(% of government expenditure on education) of Secondary in 2006 to that in 2009?
Make the answer very short. 1.07. What is the ratio of the Expenditure(% of government expenditure on education) of Tertiary in 2006 to that in 2009?
Give a very brief answer. 1.28. What is the ratio of the Expenditure(% of government expenditure on education) in Primary in 2006 to that in 2010?
Your answer should be very brief. 0.89. What is the ratio of the Expenditure(% of government expenditure on education) in Secondary in 2006 to that in 2010?
Provide a short and direct response. 1.12. What is the ratio of the Expenditure(% of government expenditure on education) in Tertiary in 2006 to that in 2010?
Ensure brevity in your answer.  1.13. What is the ratio of the Expenditure(% of government expenditure on education) in Primary in 2006 to that in 2011?
Your answer should be compact. 0.92. What is the ratio of the Expenditure(% of government expenditure on education) of Secondary in 2006 to that in 2011?
Your answer should be compact. 1.24. What is the ratio of the Expenditure(% of government expenditure on education) of Tertiary in 2006 to that in 2011?
Give a very brief answer. 0.88. What is the ratio of the Expenditure(% of government expenditure on education) in Primary in 2006 to that in 2012?
Make the answer very short. 0.9. What is the ratio of the Expenditure(% of government expenditure on education) of Secondary in 2006 to that in 2012?
Give a very brief answer. 1.3. What is the ratio of the Expenditure(% of government expenditure on education) in Tertiary in 2006 to that in 2012?
Provide a short and direct response. 0.86. What is the ratio of the Expenditure(% of government expenditure on education) in Primary in 2007 to that in 2008?
Provide a succinct answer. 0.93. What is the ratio of the Expenditure(% of government expenditure on education) in Secondary in 2007 to that in 2008?
Ensure brevity in your answer.  1.02. What is the ratio of the Expenditure(% of government expenditure on education) of Tertiary in 2007 to that in 2008?
Your answer should be compact. 1.07. What is the ratio of the Expenditure(% of government expenditure on education) of Primary in 2007 to that in 2009?
Keep it short and to the point. 0.88. What is the ratio of the Expenditure(% of government expenditure on education) of Secondary in 2007 to that in 2009?
Provide a short and direct response. 1.03. What is the ratio of the Expenditure(% of government expenditure on education) of Tertiary in 2007 to that in 2009?
Ensure brevity in your answer.  1.33. What is the ratio of the Expenditure(% of government expenditure on education) in Primary in 2007 to that in 2010?
Provide a short and direct response. 0.87. What is the ratio of the Expenditure(% of government expenditure on education) in Secondary in 2007 to that in 2010?
Your response must be concise. 1.08. What is the ratio of the Expenditure(% of government expenditure on education) of Tertiary in 2007 to that in 2010?
Keep it short and to the point. 1.17. What is the ratio of the Expenditure(% of government expenditure on education) of Primary in 2007 to that in 2011?
Your response must be concise. 0.9. What is the ratio of the Expenditure(% of government expenditure on education) of Secondary in 2007 to that in 2011?
Your answer should be compact. 1.2. What is the ratio of the Expenditure(% of government expenditure on education) of Tertiary in 2007 to that in 2011?
Provide a succinct answer. 0.91. What is the ratio of the Expenditure(% of government expenditure on education) in Primary in 2007 to that in 2012?
Provide a short and direct response. 0.88. What is the ratio of the Expenditure(% of government expenditure on education) of Secondary in 2007 to that in 2012?
Your response must be concise. 1.26. What is the ratio of the Expenditure(% of government expenditure on education) of Tertiary in 2007 to that in 2012?
Offer a terse response. 0.9. What is the ratio of the Expenditure(% of government expenditure on education) in Primary in 2008 to that in 2009?
Make the answer very short. 0.95. What is the ratio of the Expenditure(% of government expenditure on education) in Secondary in 2008 to that in 2009?
Offer a very short reply. 1.01. What is the ratio of the Expenditure(% of government expenditure on education) of Tertiary in 2008 to that in 2009?
Your response must be concise. 1.24. What is the ratio of the Expenditure(% of government expenditure on education) in Primary in 2008 to that in 2010?
Your answer should be very brief. 0.94. What is the ratio of the Expenditure(% of government expenditure on education) of Secondary in 2008 to that in 2010?
Your answer should be very brief. 1.06. What is the ratio of the Expenditure(% of government expenditure on education) of Tertiary in 2008 to that in 2010?
Your answer should be compact. 1.09. What is the ratio of the Expenditure(% of government expenditure on education) in Primary in 2008 to that in 2011?
Keep it short and to the point. 0.97. What is the ratio of the Expenditure(% of government expenditure on education) of Secondary in 2008 to that in 2011?
Your answer should be compact. 1.17. What is the ratio of the Expenditure(% of government expenditure on education) in Tertiary in 2008 to that in 2011?
Keep it short and to the point. 0.85. What is the ratio of the Expenditure(% of government expenditure on education) of Primary in 2008 to that in 2012?
Offer a terse response. 0.95. What is the ratio of the Expenditure(% of government expenditure on education) in Secondary in 2008 to that in 2012?
Offer a very short reply. 1.23. What is the ratio of the Expenditure(% of government expenditure on education) of Tertiary in 2008 to that in 2012?
Your response must be concise. 0.84. What is the ratio of the Expenditure(% of government expenditure on education) of Secondary in 2009 to that in 2010?
Ensure brevity in your answer.  1.05. What is the ratio of the Expenditure(% of government expenditure on education) of Tertiary in 2009 to that in 2010?
Your answer should be compact. 0.88. What is the ratio of the Expenditure(% of government expenditure on education) in Primary in 2009 to that in 2011?
Your response must be concise. 1.02. What is the ratio of the Expenditure(% of government expenditure on education) of Secondary in 2009 to that in 2011?
Your answer should be very brief. 1.16. What is the ratio of the Expenditure(% of government expenditure on education) of Tertiary in 2009 to that in 2011?
Make the answer very short. 0.68. What is the ratio of the Expenditure(% of government expenditure on education) in Secondary in 2009 to that in 2012?
Your response must be concise. 1.22. What is the ratio of the Expenditure(% of government expenditure on education) in Tertiary in 2009 to that in 2012?
Make the answer very short. 0.67. What is the ratio of the Expenditure(% of government expenditure on education) in Primary in 2010 to that in 2011?
Your answer should be very brief. 1.03. What is the ratio of the Expenditure(% of government expenditure on education) of Secondary in 2010 to that in 2011?
Make the answer very short. 1.11. What is the ratio of the Expenditure(% of government expenditure on education) in Tertiary in 2010 to that in 2011?
Ensure brevity in your answer.  0.78. What is the ratio of the Expenditure(% of government expenditure on education) in Primary in 2010 to that in 2012?
Your answer should be very brief. 1.01. What is the ratio of the Expenditure(% of government expenditure on education) in Secondary in 2010 to that in 2012?
Your response must be concise. 1.16. What is the ratio of the Expenditure(% of government expenditure on education) of Tertiary in 2010 to that in 2012?
Provide a short and direct response. 0.77. What is the ratio of the Expenditure(% of government expenditure on education) of Secondary in 2011 to that in 2012?
Keep it short and to the point. 1.05. What is the ratio of the Expenditure(% of government expenditure on education) of Tertiary in 2011 to that in 2012?
Your answer should be very brief. 0.99. What is the difference between the highest and the second highest Expenditure(% of government expenditure on education) of Primary?
Offer a very short reply. 0.3. What is the difference between the highest and the second highest Expenditure(% of government expenditure on education) of Secondary?
Your answer should be very brief. 1.83. What is the difference between the highest and the second highest Expenditure(% of government expenditure on education) of Tertiary?
Provide a succinct answer. 0.25. What is the difference between the highest and the lowest Expenditure(% of government expenditure on education) of Primary?
Provide a succinct answer. 12.2. What is the difference between the highest and the lowest Expenditure(% of government expenditure on education) of Secondary?
Keep it short and to the point. 23.44. What is the difference between the highest and the lowest Expenditure(% of government expenditure on education) of Tertiary?
Your answer should be very brief. 7.28. 